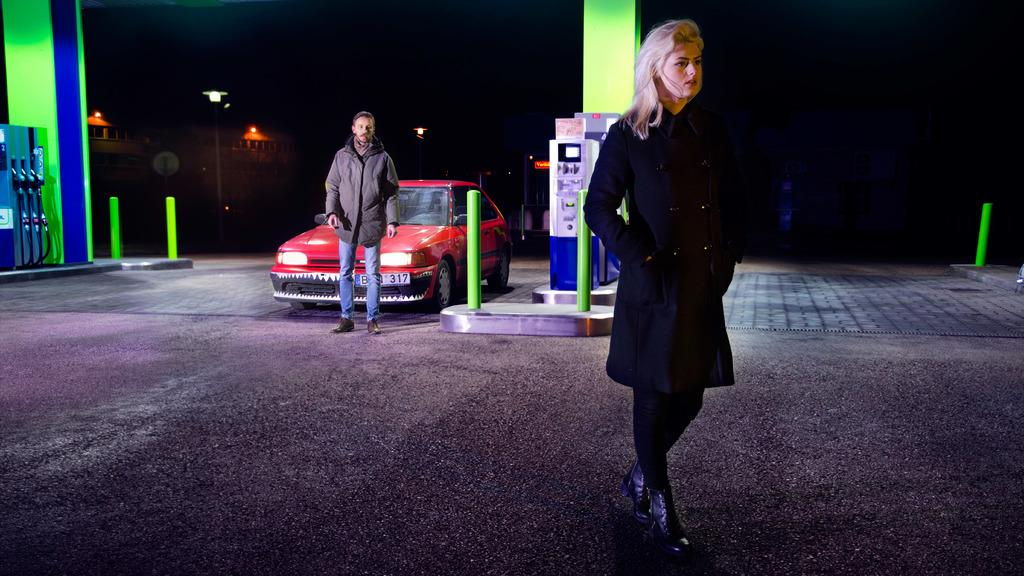How many people are on the road in the image? There are two people on the road in the image. What vehicle can be seen in the image? There is a car in the image. What objects resemble petrol pump machines? There are objects that resemble petrol pump machines in the image. What architectural features are present in the image? Pillars and buildings are present in the image. What type of structure is visible in the image? A light pole is present in the image. What is the color of the background in the image? The background of the image is dark. What type of soup is being served on the light pole in the image? There is no soup present in the image, and the light pole is not serving any food. Can you see a knife being used by the people on the road in the image? There is no knife visible in the image, and the people on the road are not using any knives. 